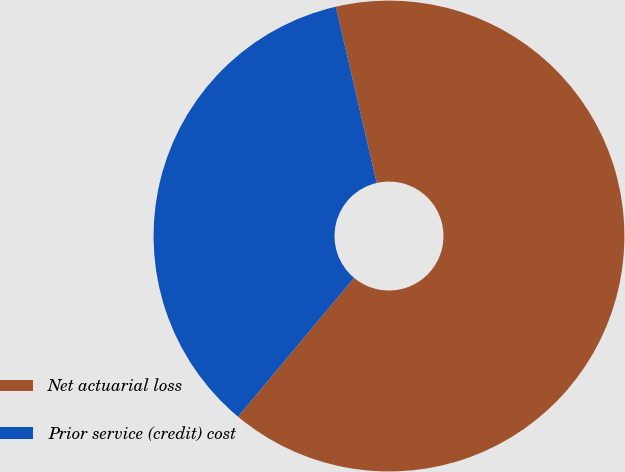Convert chart. <chart><loc_0><loc_0><loc_500><loc_500><pie_chart><fcel>Net actuarial loss<fcel>Prior service (credit) cost<nl><fcel>64.71%<fcel>35.29%<nl></chart> 